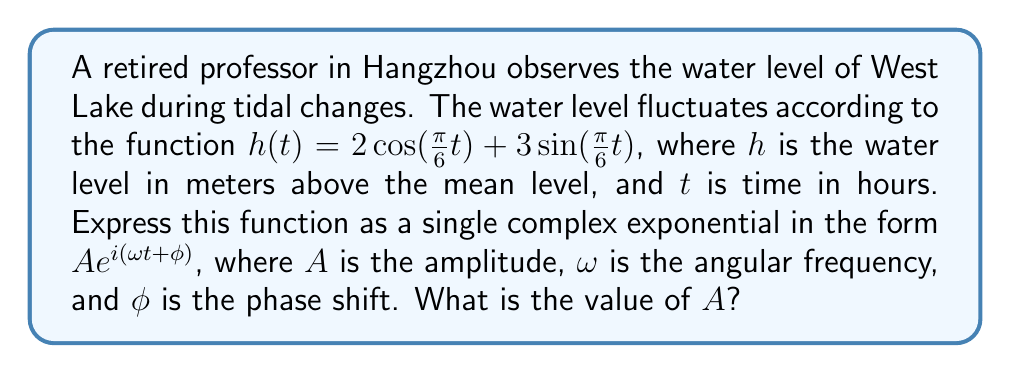Help me with this question. Let's approach this step-by-step:

1) The given function is $h(t) = 2\cos(\frac{\pi}{6}t) + 3\sin(\frac{\pi}{6}t)$

2) We can rewrite this in complex form using Euler's formula:
   $e^{ix} = \cos(x) + i\sin(x)$

3) Let $z = 2 - 3i$. Then our function can be written as:
   $h(t) = \text{Re}(z e^{i\frac{\pi}{6}t})$

4) To get it in the form $A e^{i(\omega t + \phi)}$, we need to find the modulus and argument of $z$:

   $A = |z| = \sqrt{2^2 + 3^2} = \sqrt{13}$

   $\phi = \arg(z) = \arctan(-\frac{3}{2}) = -\arctan(\frac{3}{2})$

5) Now we can write:
   $z = \sqrt{13} e^{-i\arctan(\frac{3}{2})}$

6) Therefore, our function can be expressed as:
   $h(t) = \text{Re}(\sqrt{13} e^{i(\frac{\pi}{6}t - \arctan(\frac{3}{2}))})$

7) Comparing with the form $A e^{i(\omega t + \phi)}$, we see that:
   $A = \sqrt{13}$
   $\omega = \frac{\pi}{6}$
   $\phi = -\arctan(\frac{3}{2})$

The question asks for the value of $A$.
Answer: $\sqrt{13}$ 